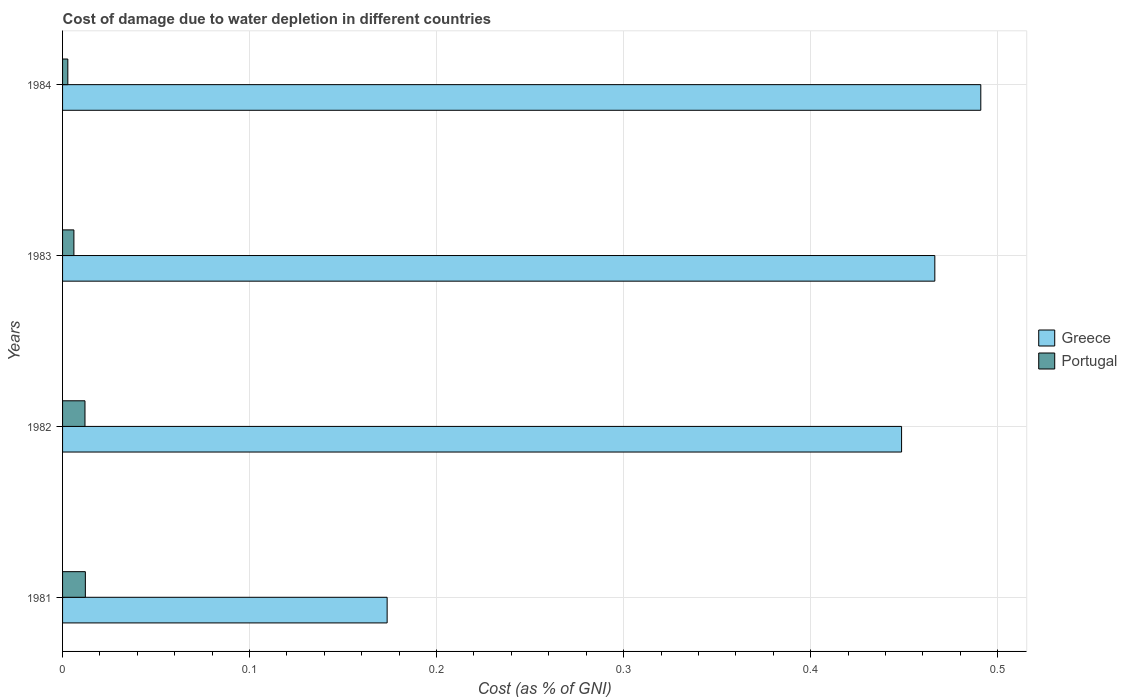How many different coloured bars are there?
Provide a short and direct response. 2. Are the number of bars per tick equal to the number of legend labels?
Provide a succinct answer. Yes. How many bars are there on the 2nd tick from the top?
Your answer should be compact. 2. How many bars are there on the 1st tick from the bottom?
Your answer should be very brief. 2. What is the label of the 4th group of bars from the top?
Your answer should be very brief. 1981. What is the cost of damage caused due to water depletion in Portugal in 1982?
Make the answer very short. 0.01. Across all years, what is the maximum cost of damage caused due to water depletion in Portugal?
Provide a short and direct response. 0.01. Across all years, what is the minimum cost of damage caused due to water depletion in Greece?
Provide a succinct answer. 0.17. In which year was the cost of damage caused due to water depletion in Greece minimum?
Offer a very short reply. 1981. What is the total cost of damage caused due to water depletion in Greece in the graph?
Your answer should be compact. 1.58. What is the difference between the cost of damage caused due to water depletion in Greece in 1982 and that in 1984?
Provide a succinct answer. -0.04. What is the difference between the cost of damage caused due to water depletion in Portugal in 1981 and the cost of damage caused due to water depletion in Greece in 1984?
Provide a short and direct response. -0.48. What is the average cost of damage caused due to water depletion in Portugal per year?
Offer a terse response. 0.01. In the year 1984, what is the difference between the cost of damage caused due to water depletion in Greece and cost of damage caused due to water depletion in Portugal?
Keep it short and to the point. 0.49. What is the ratio of the cost of damage caused due to water depletion in Portugal in 1982 to that in 1984?
Your answer should be very brief. 4.27. What is the difference between the highest and the second highest cost of damage caused due to water depletion in Portugal?
Provide a succinct answer. 0. What is the difference between the highest and the lowest cost of damage caused due to water depletion in Greece?
Keep it short and to the point. 0.32. What does the 2nd bar from the bottom in 1981 represents?
Provide a succinct answer. Portugal. How many bars are there?
Make the answer very short. 8. Are all the bars in the graph horizontal?
Make the answer very short. Yes. What is the difference between two consecutive major ticks on the X-axis?
Your answer should be very brief. 0.1. Are the values on the major ticks of X-axis written in scientific E-notation?
Your answer should be very brief. No. Does the graph contain any zero values?
Make the answer very short. No. Where does the legend appear in the graph?
Offer a terse response. Center right. How many legend labels are there?
Make the answer very short. 2. What is the title of the graph?
Provide a succinct answer. Cost of damage due to water depletion in different countries. Does "Slovak Republic" appear as one of the legend labels in the graph?
Keep it short and to the point. No. What is the label or title of the X-axis?
Offer a very short reply. Cost (as % of GNI). What is the Cost (as % of GNI) in Greece in 1981?
Provide a short and direct response. 0.17. What is the Cost (as % of GNI) in Portugal in 1981?
Your response must be concise. 0.01. What is the Cost (as % of GNI) of Greece in 1982?
Offer a terse response. 0.45. What is the Cost (as % of GNI) of Portugal in 1982?
Offer a very short reply. 0.01. What is the Cost (as % of GNI) in Greece in 1983?
Ensure brevity in your answer.  0.47. What is the Cost (as % of GNI) of Portugal in 1983?
Your answer should be compact. 0.01. What is the Cost (as % of GNI) of Greece in 1984?
Provide a short and direct response. 0.49. What is the Cost (as % of GNI) in Portugal in 1984?
Provide a succinct answer. 0. Across all years, what is the maximum Cost (as % of GNI) of Greece?
Your response must be concise. 0.49. Across all years, what is the maximum Cost (as % of GNI) of Portugal?
Your answer should be very brief. 0.01. Across all years, what is the minimum Cost (as % of GNI) of Greece?
Make the answer very short. 0.17. Across all years, what is the minimum Cost (as % of GNI) of Portugal?
Offer a terse response. 0. What is the total Cost (as % of GNI) in Greece in the graph?
Ensure brevity in your answer.  1.58. What is the total Cost (as % of GNI) in Portugal in the graph?
Offer a very short reply. 0.03. What is the difference between the Cost (as % of GNI) in Greece in 1981 and that in 1982?
Ensure brevity in your answer.  -0.28. What is the difference between the Cost (as % of GNI) in Portugal in 1981 and that in 1982?
Offer a very short reply. 0. What is the difference between the Cost (as % of GNI) in Greece in 1981 and that in 1983?
Give a very brief answer. -0.29. What is the difference between the Cost (as % of GNI) of Portugal in 1981 and that in 1983?
Keep it short and to the point. 0.01. What is the difference between the Cost (as % of GNI) of Greece in 1981 and that in 1984?
Your response must be concise. -0.32. What is the difference between the Cost (as % of GNI) in Portugal in 1981 and that in 1984?
Your answer should be very brief. 0.01. What is the difference between the Cost (as % of GNI) in Greece in 1982 and that in 1983?
Provide a succinct answer. -0.02. What is the difference between the Cost (as % of GNI) in Portugal in 1982 and that in 1983?
Offer a very short reply. 0.01. What is the difference between the Cost (as % of GNI) of Greece in 1982 and that in 1984?
Provide a short and direct response. -0.04. What is the difference between the Cost (as % of GNI) in Portugal in 1982 and that in 1984?
Offer a terse response. 0.01. What is the difference between the Cost (as % of GNI) in Greece in 1983 and that in 1984?
Make the answer very short. -0.02. What is the difference between the Cost (as % of GNI) of Portugal in 1983 and that in 1984?
Provide a short and direct response. 0. What is the difference between the Cost (as % of GNI) in Greece in 1981 and the Cost (as % of GNI) in Portugal in 1982?
Your answer should be very brief. 0.16. What is the difference between the Cost (as % of GNI) of Greece in 1981 and the Cost (as % of GNI) of Portugal in 1983?
Offer a terse response. 0.17. What is the difference between the Cost (as % of GNI) in Greece in 1981 and the Cost (as % of GNI) in Portugal in 1984?
Provide a succinct answer. 0.17. What is the difference between the Cost (as % of GNI) in Greece in 1982 and the Cost (as % of GNI) in Portugal in 1983?
Make the answer very short. 0.44. What is the difference between the Cost (as % of GNI) of Greece in 1982 and the Cost (as % of GNI) of Portugal in 1984?
Your answer should be very brief. 0.45. What is the difference between the Cost (as % of GNI) in Greece in 1983 and the Cost (as % of GNI) in Portugal in 1984?
Make the answer very short. 0.46. What is the average Cost (as % of GNI) in Greece per year?
Provide a succinct answer. 0.39. What is the average Cost (as % of GNI) of Portugal per year?
Provide a short and direct response. 0.01. In the year 1981, what is the difference between the Cost (as % of GNI) in Greece and Cost (as % of GNI) in Portugal?
Offer a very short reply. 0.16. In the year 1982, what is the difference between the Cost (as % of GNI) of Greece and Cost (as % of GNI) of Portugal?
Keep it short and to the point. 0.44. In the year 1983, what is the difference between the Cost (as % of GNI) of Greece and Cost (as % of GNI) of Portugal?
Offer a terse response. 0.46. In the year 1984, what is the difference between the Cost (as % of GNI) in Greece and Cost (as % of GNI) in Portugal?
Ensure brevity in your answer.  0.49. What is the ratio of the Cost (as % of GNI) of Greece in 1981 to that in 1982?
Provide a succinct answer. 0.39. What is the ratio of the Cost (as % of GNI) in Portugal in 1981 to that in 1982?
Give a very brief answer. 1.02. What is the ratio of the Cost (as % of GNI) of Greece in 1981 to that in 1983?
Provide a succinct answer. 0.37. What is the ratio of the Cost (as % of GNI) of Portugal in 1981 to that in 1983?
Make the answer very short. 2.01. What is the ratio of the Cost (as % of GNI) in Greece in 1981 to that in 1984?
Offer a terse response. 0.35. What is the ratio of the Cost (as % of GNI) in Portugal in 1981 to that in 1984?
Your answer should be very brief. 4.34. What is the ratio of the Cost (as % of GNI) in Greece in 1982 to that in 1983?
Make the answer very short. 0.96. What is the ratio of the Cost (as % of GNI) of Portugal in 1982 to that in 1983?
Offer a very short reply. 1.98. What is the ratio of the Cost (as % of GNI) in Greece in 1982 to that in 1984?
Offer a very short reply. 0.91. What is the ratio of the Cost (as % of GNI) in Portugal in 1982 to that in 1984?
Give a very brief answer. 4.27. What is the ratio of the Cost (as % of GNI) of Greece in 1983 to that in 1984?
Your response must be concise. 0.95. What is the ratio of the Cost (as % of GNI) in Portugal in 1983 to that in 1984?
Offer a terse response. 2.16. What is the difference between the highest and the second highest Cost (as % of GNI) of Greece?
Your response must be concise. 0.02. What is the difference between the highest and the lowest Cost (as % of GNI) in Greece?
Your response must be concise. 0.32. What is the difference between the highest and the lowest Cost (as % of GNI) in Portugal?
Ensure brevity in your answer.  0.01. 